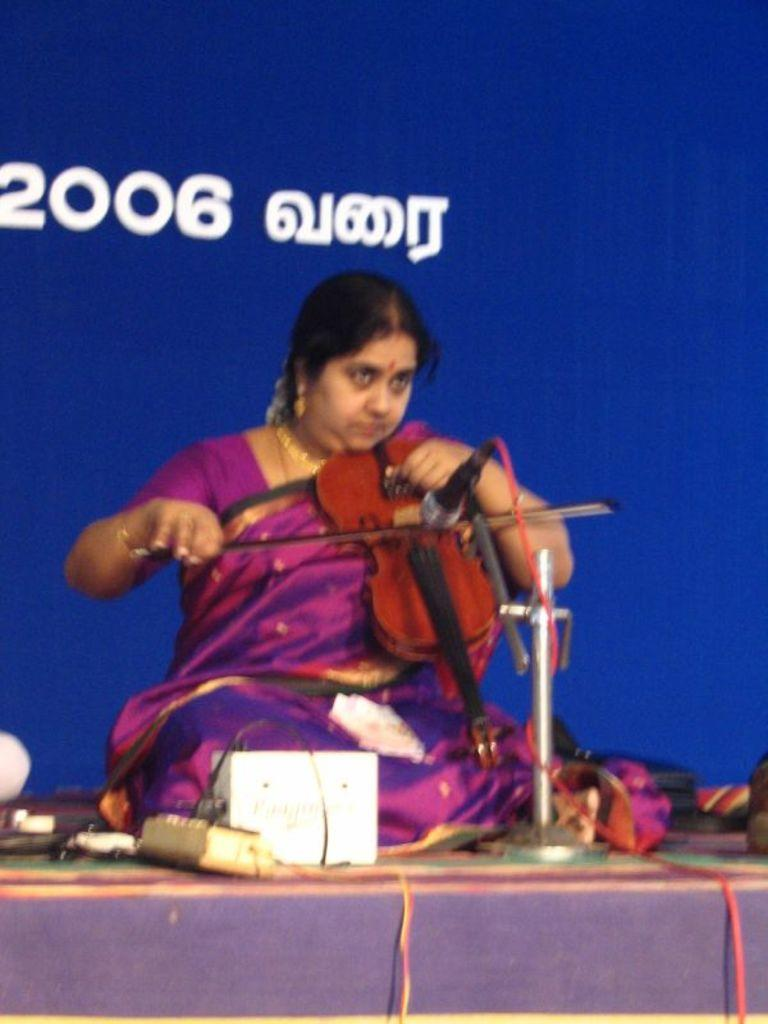Who is the main subject in the image? There is a woman in the image. What is the woman doing in the image? The woman is playing a violin. What is the purpose of the microphone in front of the woman? The microphone is likely used for amplifying the sound of the violin. What can be seen behind the woman? There is a banner behind the woman. What other objects are in front of the woman? There are other objects in front of the woman, but their specific details are not mentioned in the facts. What type of watch is the maid wearing in the image? There is no maid or watch present in the image. Can you tell me how many cans are visible in the image? There is no mention of cans in the image, so it is not possible to determine their presence or quantity. 